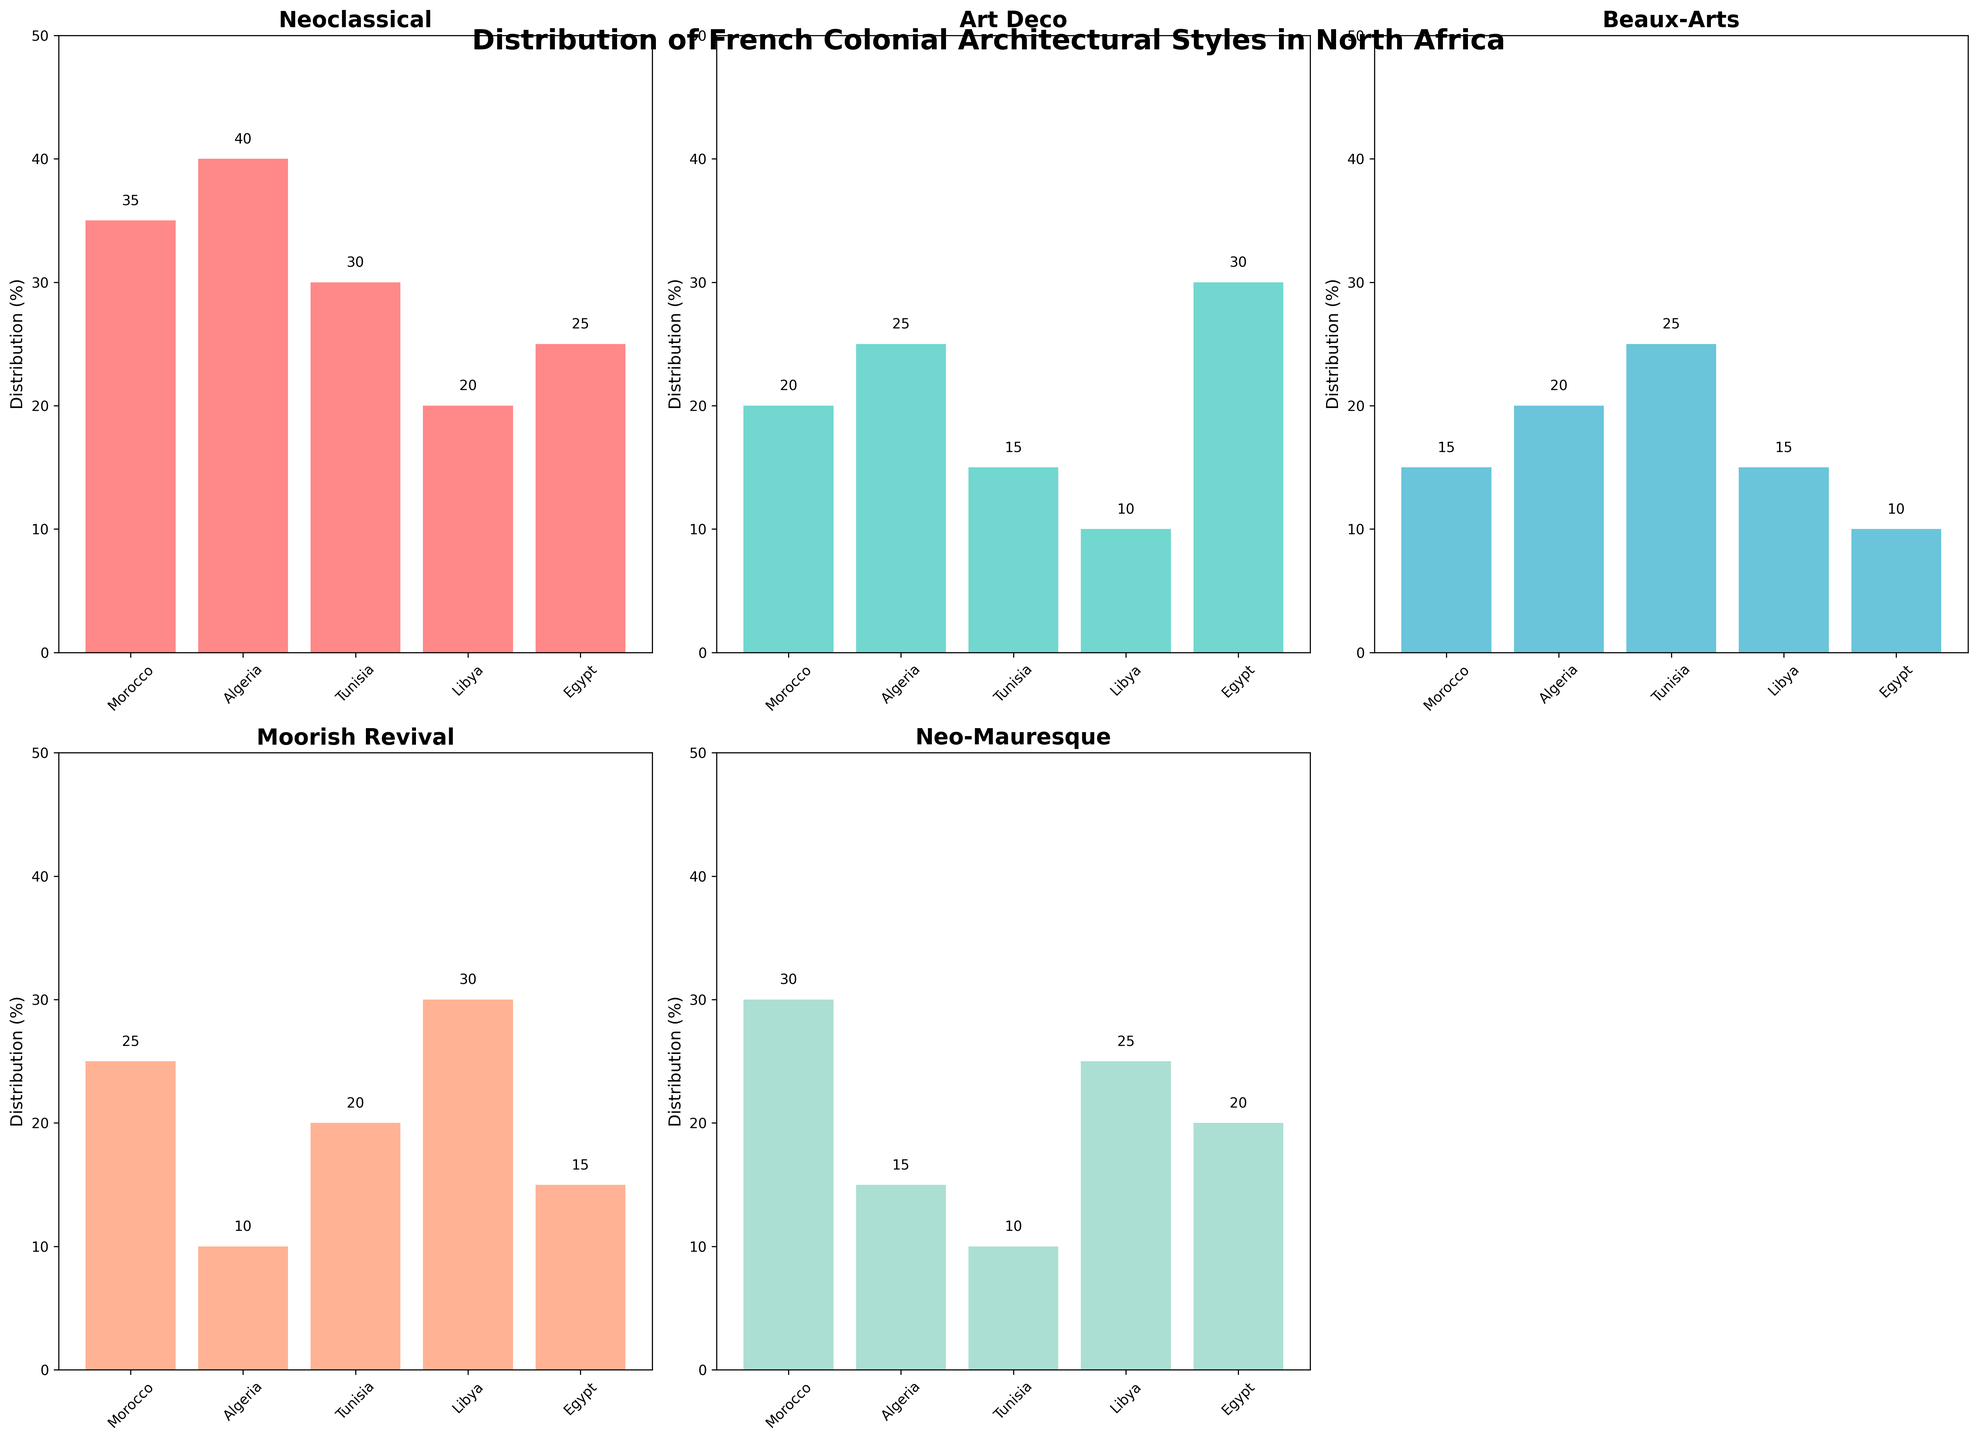What is the title of the figure? The title of the figure is written at the top and reads "Distribution of French Colonial Architectural Styles in North Africa".
Answer: Distribution of French Colonial Architectural Styles in North Africa Which country has the highest percentage of Neoclassical architecture? Looking at the Neoclassical subplot, the bar for Algeria is the tallest, indicating the highest percentage.
Answer: Algeria How many architectural styles are depicted in the figure? There are five subplots, each representing a different architectural style.
Answer: Five What is the total percentage of Neo-Mauresque architecture in Morocco and Algeria combined? In the Neo-Mauresque subplot, Morocco has a percentage of 30, and Algeria has 15. Adding these together (30 + 15) gives 45.
Answer: 45 Which architectural style is most prevalent in Egypt? In the Egypt bars across all subplots, the tallest bar is in the Art Deco subplot, indicating this is the most prevalent style.
Answer: Art Deco Which country shows the most balanced (least disparity) distribution among the architectural styles? By evaluating the height of the bars across all subplots, Morocco appears to have a more balanced distribution compared to the other countries. The heights are relatively similar.
Answer: Morocco Is there any country where Moorish Revival architecture is the most common style? By looking at the Moorish Revival subplot, Libya stands out as having the highest percentage at 30. This is the tallest bar for Libya across all subplots, making it the most common style there.
Answer: Yes, Libya Compare the distribution of Art Deco architecture between Egypt and Tunisia. Which country has a higher percentage? Comparing the bars in the Art Deco subplot, Egypt's bar is higher at 30% compared to Tunisia's 15%.
Answer: Egypt In which architectural style does Libya have the lowest percentage? Looking across all subplots for Libya, the lowest percentage is in the Art Deco style with 10%.
Answer: Art Deco Which countries have a higher percentage of Beaux-Arts architecture than Neo-Mauresque? By comparing the heights in the Beaux-Arts and Neo-Mauresque subplots, Algeria and Tunisia have higher percentages in Beaux-Arts (20% and 25%, respectively) than in Neo-Mauresque (15% and 10%).
Answer: Algeria, Tunisia 